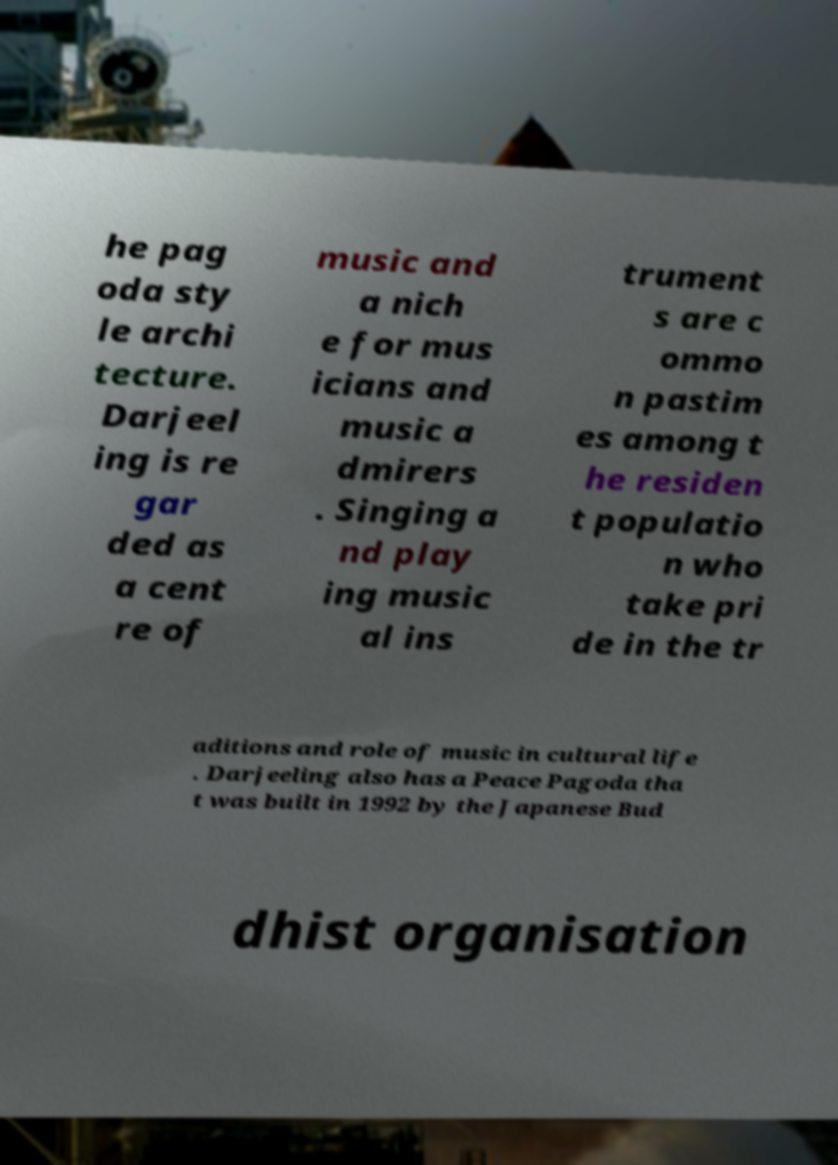There's text embedded in this image that I need extracted. Can you transcribe it verbatim? he pag oda sty le archi tecture. Darjeel ing is re gar ded as a cent re of music and a nich e for mus icians and music a dmirers . Singing a nd play ing music al ins trument s are c ommo n pastim es among t he residen t populatio n who take pri de in the tr aditions and role of music in cultural life . Darjeeling also has a Peace Pagoda tha t was built in 1992 by the Japanese Bud dhist organisation 